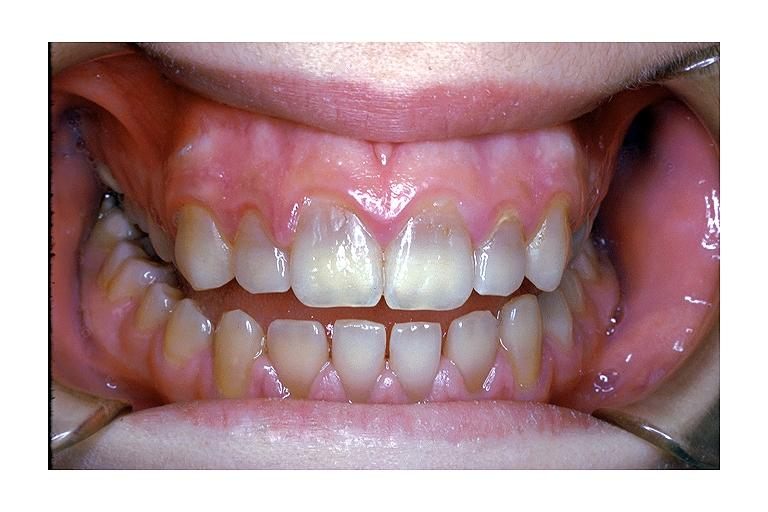what is present?
Answer the question using a single word or phrase. Oral 